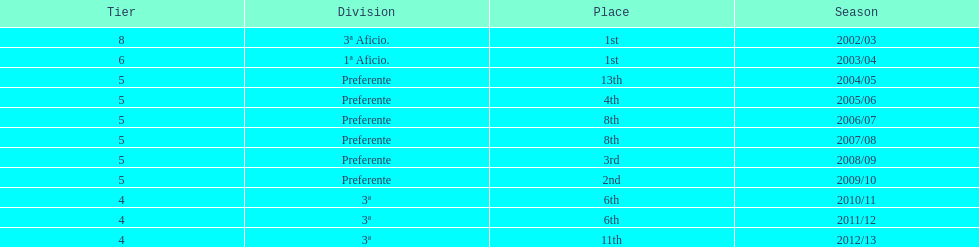I'm looking to parse the entire table for insights. Could you assist me with that? {'header': ['Tier', 'Division', 'Place', 'Season'], 'rows': [['8', '3ª Aficio.', '1st', '2002/03'], ['6', '1ª Aficio.', '1st', '2003/04'], ['5', 'Preferente', '13th', '2004/05'], ['5', 'Preferente', '4th', '2005/06'], ['5', 'Preferente', '8th', '2006/07'], ['5', 'Preferente', '8th', '2007/08'], ['5', 'Preferente', '3rd', '2008/09'], ['5', 'Preferente', '2nd', '2009/10'], ['4', '3ª', '6th', '2010/11'], ['4', '3ª', '6th', '2011/12'], ['4', '3ª', '11th', '2012/13']]} What was the number of wins for preferente? 6. 